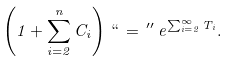Convert formula to latex. <formula><loc_0><loc_0><loc_500><loc_500>\left ( 1 + \sum _ { i = 2 } ^ { n } C _ { i } \right ) \, ` ` \, = \, ^ { \prime \prime } \, e ^ { \sum _ { i = 2 } ^ { \infty } T _ { i } } .</formula> 